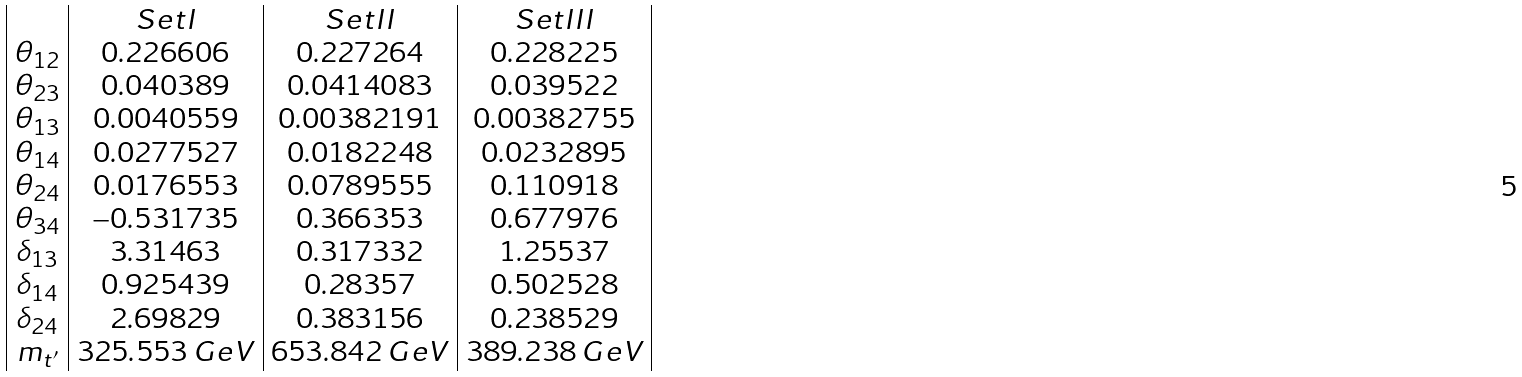Convert formula to latex. <formula><loc_0><loc_0><loc_500><loc_500>\begin{array} { | c | c | c | c | } & S e t I & S e t I I & S e t I I I \\ \theta _ { 1 2 } & 0 . 2 2 6 6 0 6 & 0 . 2 2 7 2 6 4 & 0 . 2 2 8 2 2 5 \\ \theta _ { 2 3 } & 0 . 0 4 0 3 8 9 & 0 . 0 4 1 4 0 8 3 & 0 . 0 3 9 5 2 2 \\ \theta _ { 1 3 } & 0 . 0 0 4 0 5 5 9 & 0 . 0 0 3 8 2 1 9 1 & 0 . 0 0 3 8 2 7 5 5 \\ \theta _ { 1 4 } & 0 . 0 2 7 7 5 2 7 & 0 . 0 1 8 2 2 4 8 & 0 . 0 2 3 2 8 9 5 \\ \theta _ { 2 4 } & 0 . 0 1 7 6 5 5 3 & 0 . 0 7 8 9 5 5 5 & 0 . 1 1 0 9 1 8 \\ \theta _ { 3 4 } & - 0 . 5 3 1 7 3 5 & 0 . 3 6 6 3 5 3 & 0 . 6 7 7 9 7 6 \\ \delta _ { 1 3 } & 3 . 3 1 4 6 3 & 0 . 3 1 7 3 3 2 & 1 . 2 5 5 3 7 \\ \delta _ { 1 4 } & 0 . 9 2 5 4 3 9 & 0 . 2 8 3 5 7 & 0 . 5 0 2 5 2 8 \\ \delta _ { 2 4 } & 2 . 6 9 8 2 9 & 0 . 3 8 3 1 5 6 & 0 . 2 3 8 5 2 9 \\ m _ { t ^ { \prime } } & 3 2 5 . 5 5 3 \, G e V & 6 5 3 . 8 4 2 \, G e V & 3 8 9 . 2 3 8 \, G e V \\ \end{array}</formula> 